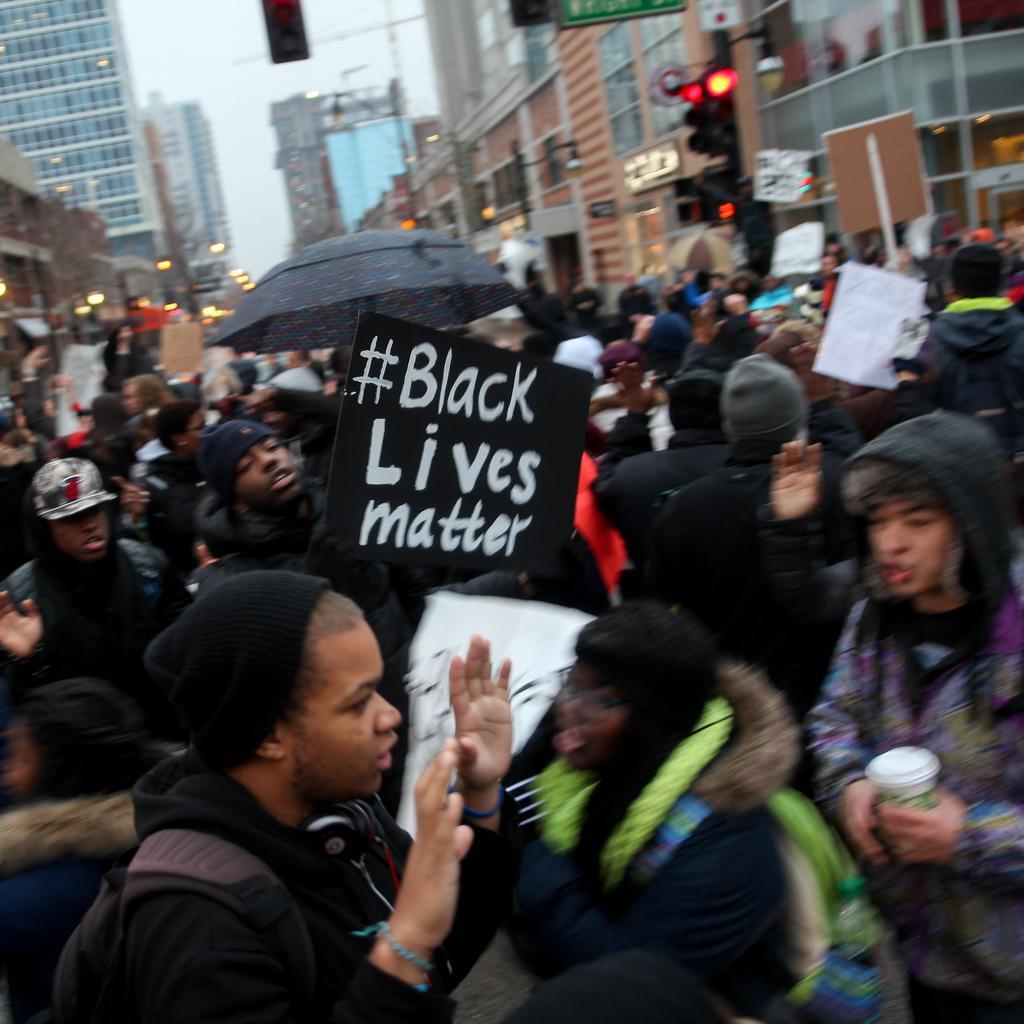Could you give a brief overview of what you see in this image? In this image we can see people standing on the road and some of them are holding papers and placards in their hands. In the background there are buildings, traffic poles, traffic signals, construction cranes, street poles, street lights and sky. 